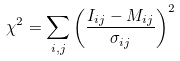<formula> <loc_0><loc_0><loc_500><loc_500>\chi ^ { 2 } = \sum _ { i , j } \left ( \frac { I _ { i j } - M _ { i j } } { \sigma _ { i j } } \right ) ^ { 2 }</formula> 